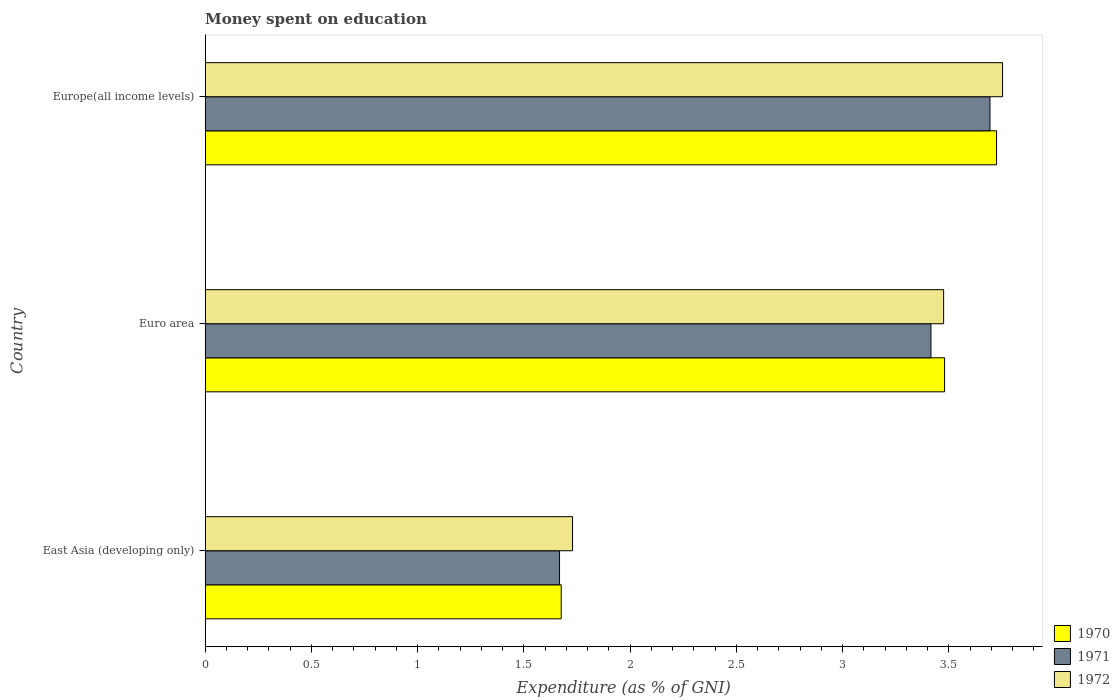How many groups of bars are there?
Offer a very short reply. 3. Are the number of bars on each tick of the Y-axis equal?
Keep it short and to the point. Yes. How many bars are there on the 1st tick from the top?
Keep it short and to the point. 3. How many bars are there on the 2nd tick from the bottom?
Keep it short and to the point. 3. What is the label of the 3rd group of bars from the top?
Provide a succinct answer. East Asia (developing only). What is the amount of money spent on education in 1971 in Euro area?
Ensure brevity in your answer.  3.42. Across all countries, what is the maximum amount of money spent on education in 1971?
Give a very brief answer. 3.69. Across all countries, what is the minimum amount of money spent on education in 1970?
Your response must be concise. 1.68. In which country was the amount of money spent on education in 1970 maximum?
Offer a terse response. Europe(all income levels). In which country was the amount of money spent on education in 1970 minimum?
Provide a succinct answer. East Asia (developing only). What is the total amount of money spent on education in 1972 in the graph?
Provide a succinct answer. 8.96. What is the difference between the amount of money spent on education in 1970 in East Asia (developing only) and that in Euro area?
Make the answer very short. -1.8. What is the difference between the amount of money spent on education in 1972 in Europe(all income levels) and the amount of money spent on education in 1971 in East Asia (developing only)?
Keep it short and to the point. 2.08. What is the average amount of money spent on education in 1971 per country?
Ensure brevity in your answer.  2.93. What is the difference between the amount of money spent on education in 1971 and amount of money spent on education in 1970 in Europe(all income levels)?
Provide a succinct answer. -0.03. What is the ratio of the amount of money spent on education in 1972 in Euro area to that in Europe(all income levels)?
Keep it short and to the point. 0.93. Is the amount of money spent on education in 1972 in Euro area less than that in Europe(all income levels)?
Offer a very short reply. Yes. What is the difference between the highest and the second highest amount of money spent on education in 1972?
Make the answer very short. 0.28. What is the difference between the highest and the lowest amount of money spent on education in 1972?
Offer a very short reply. 2.02. In how many countries, is the amount of money spent on education in 1972 greater than the average amount of money spent on education in 1972 taken over all countries?
Your answer should be compact. 2. Is the sum of the amount of money spent on education in 1971 in East Asia (developing only) and Euro area greater than the maximum amount of money spent on education in 1970 across all countries?
Your answer should be compact. Yes. What does the 2nd bar from the top in Europe(all income levels) represents?
Ensure brevity in your answer.  1971. What does the 1st bar from the bottom in Europe(all income levels) represents?
Provide a succinct answer. 1970. Are all the bars in the graph horizontal?
Provide a succinct answer. Yes. What is the difference between two consecutive major ticks on the X-axis?
Keep it short and to the point. 0.5. Are the values on the major ticks of X-axis written in scientific E-notation?
Your answer should be very brief. No. Where does the legend appear in the graph?
Offer a terse response. Bottom right. How many legend labels are there?
Your answer should be very brief. 3. What is the title of the graph?
Offer a terse response. Money spent on education. Does "2010" appear as one of the legend labels in the graph?
Give a very brief answer. No. What is the label or title of the X-axis?
Your response must be concise. Expenditure (as % of GNI). What is the Expenditure (as % of GNI) of 1970 in East Asia (developing only)?
Keep it short and to the point. 1.68. What is the Expenditure (as % of GNI) of 1971 in East Asia (developing only)?
Provide a short and direct response. 1.67. What is the Expenditure (as % of GNI) in 1972 in East Asia (developing only)?
Provide a short and direct response. 1.73. What is the Expenditure (as % of GNI) of 1970 in Euro area?
Offer a terse response. 3.48. What is the Expenditure (as % of GNI) of 1971 in Euro area?
Your answer should be compact. 3.42. What is the Expenditure (as % of GNI) in 1972 in Euro area?
Provide a succinct answer. 3.47. What is the Expenditure (as % of GNI) of 1970 in Europe(all income levels)?
Ensure brevity in your answer.  3.72. What is the Expenditure (as % of GNI) in 1971 in Europe(all income levels)?
Your response must be concise. 3.69. What is the Expenditure (as % of GNI) of 1972 in Europe(all income levels)?
Provide a short and direct response. 3.75. Across all countries, what is the maximum Expenditure (as % of GNI) in 1970?
Your response must be concise. 3.72. Across all countries, what is the maximum Expenditure (as % of GNI) of 1971?
Offer a very short reply. 3.69. Across all countries, what is the maximum Expenditure (as % of GNI) of 1972?
Make the answer very short. 3.75. Across all countries, what is the minimum Expenditure (as % of GNI) in 1970?
Keep it short and to the point. 1.68. Across all countries, what is the minimum Expenditure (as % of GNI) of 1971?
Your answer should be very brief. 1.67. Across all countries, what is the minimum Expenditure (as % of GNI) in 1972?
Offer a very short reply. 1.73. What is the total Expenditure (as % of GNI) in 1970 in the graph?
Provide a succinct answer. 8.88. What is the total Expenditure (as % of GNI) in 1971 in the graph?
Offer a terse response. 8.78. What is the total Expenditure (as % of GNI) of 1972 in the graph?
Ensure brevity in your answer.  8.96. What is the difference between the Expenditure (as % of GNI) of 1970 in East Asia (developing only) and that in Euro area?
Make the answer very short. -1.8. What is the difference between the Expenditure (as % of GNI) of 1971 in East Asia (developing only) and that in Euro area?
Ensure brevity in your answer.  -1.75. What is the difference between the Expenditure (as % of GNI) of 1972 in East Asia (developing only) and that in Euro area?
Your answer should be compact. -1.75. What is the difference between the Expenditure (as % of GNI) of 1970 in East Asia (developing only) and that in Europe(all income levels)?
Give a very brief answer. -2.05. What is the difference between the Expenditure (as % of GNI) of 1971 in East Asia (developing only) and that in Europe(all income levels)?
Your response must be concise. -2.03. What is the difference between the Expenditure (as % of GNI) in 1972 in East Asia (developing only) and that in Europe(all income levels)?
Ensure brevity in your answer.  -2.02. What is the difference between the Expenditure (as % of GNI) of 1970 in Euro area and that in Europe(all income levels)?
Ensure brevity in your answer.  -0.24. What is the difference between the Expenditure (as % of GNI) of 1971 in Euro area and that in Europe(all income levels)?
Your answer should be compact. -0.28. What is the difference between the Expenditure (as % of GNI) in 1972 in Euro area and that in Europe(all income levels)?
Provide a succinct answer. -0.28. What is the difference between the Expenditure (as % of GNI) of 1970 in East Asia (developing only) and the Expenditure (as % of GNI) of 1971 in Euro area?
Provide a short and direct response. -1.74. What is the difference between the Expenditure (as % of GNI) in 1970 in East Asia (developing only) and the Expenditure (as % of GNI) in 1972 in Euro area?
Your answer should be very brief. -1.8. What is the difference between the Expenditure (as % of GNI) in 1971 in East Asia (developing only) and the Expenditure (as % of GNI) in 1972 in Euro area?
Ensure brevity in your answer.  -1.81. What is the difference between the Expenditure (as % of GNI) in 1970 in East Asia (developing only) and the Expenditure (as % of GNI) in 1971 in Europe(all income levels)?
Provide a succinct answer. -2.02. What is the difference between the Expenditure (as % of GNI) in 1970 in East Asia (developing only) and the Expenditure (as % of GNI) in 1972 in Europe(all income levels)?
Keep it short and to the point. -2.08. What is the difference between the Expenditure (as % of GNI) of 1971 in East Asia (developing only) and the Expenditure (as % of GNI) of 1972 in Europe(all income levels)?
Provide a short and direct response. -2.08. What is the difference between the Expenditure (as % of GNI) in 1970 in Euro area and the Expenditure (as % of GNI) in 1971 in Europe(all income levels)?
Your answer should be very brief. -0.21. What is the difference between the Expenditure (as % of GNI) of 1970 in Euro area and the Expenditure (as % of GNI) of 1972 in Europe(all income levels)?
Your response must be concise. -0.27. What is the difference between the Expenditure (as % of GNI) in 1971 in Euro area and the Expenditure (as % of GNI) in 1972 in Europe(all income levels)?
Your answer should be compact. -0.34. What is the average Expenditure (as % of GNI) of 1970 per country?
Offer a terse response. 2.96. What is the average Expenditure (as % of GNI) in 1971 per country?
Provide a short and direct response. 2.93. What is the average Expenditure (as % of GNI) of 1972 per country?
Give a very brief answer. 2.99. What is the difference between the Expenditure (as % of GNI) in 1970 and Expenditure (as % of GNI) in 1971 in East Asia (developing only)?
Your answer should be very brief. 0.01. What is the difference between the Expenditure (as % of GNI) of 1970 and Expenditure (as % of GNI) of 1972 in East Asia (developing only)?
Keep it short and to the point. -0.05. What is the difference between the Expenditure (as % of GNI) in 1971 and Expenditure (as % of GNI) in 1972 in East Asia (developing only)?
Provide a short and direct response. -0.06. What is the difference between the Expenditure (as % of GNI) of 1970 and Expenditure (as % of GNI) of 1971 in Euro area?
Give a very brief answer. 0.06. What is the difference between the Expenditure (as % of GNI) of 1970 and Expenditure (as % of GNI) of 1972 in Euro area?
Keep it short and to the point. 0. What is the difference between the Expenditure (as % of GNI) of 1971 and Expenditure (as % of GNI) of 1972 in Euro area?
Ensure brevity in your answer.  -0.06. What is the difference between the Expenditure (as % of GNI) in 1970 and Expenditure (as % of GNI) in 1971 in Europe(all income levels)?
Offer a very short reply. 0.03. What is the difference between the Expenditure (as % of GNI) in 1970 and Expenditure (as % of GNI) in 1972 in Europe(all income levels)?
Give a very brief answer. -0.03. What is the difference between the Expenditure (as % of GNI) in 1971 and Expenditure (as % of GNI) in 1972 in Europe(all income levels)?
Give a very brief answer. -0.06. What is the ratio of the Expenditure (as % of GNI) of 1970 in East Asia (developing only) to that in Euro area?
Your answer should be compact. 0.48. What is the ratio of the Expenditure (as % of GNI) in 1971 in East Asia (developing only) to that in Euro area?
Your answer should be very brief. 0.49. What is the ratio of the Expenditure (as % of GNI) in 1972 in East Asia (developing only) to that in Euro area?
Provide a succinct answer. 0.5. What is the ratio of the Expenditure (as % of GNI) in 1970 in East Asia (developing only) to that in Europe(all income levels)?
Keep it short and to the point. 0.45. What is the ratio of the Expenditure (as % of GNI) in 1971 in East Asia (developing only) to that in Europe(all income levels)?
Your response must be concise. 0.45. What is the ratio of the Expenditure (as % of GNI) of 1972 in East Asia (developing only) to that in Europe(all income levels)?
Provide a succinct answer. 0.46. What is the ratio of the Expenditure (as % of GNI) of 1970 in Euro area to that in Europe(all income levels)?
Provide a succinct answer. 0.93. What is the ratio of the Expenditure (as % of GNI) in 1971 in Euro area to that in Europe(all income levels)?
Make the answer very short. 0.92. What is the ratio of the Expenditure (as % of GNI) of 1972 in Euro area to that in Europe(all income levels)?
Make the answer very short. 0.93. What is the difference between the highest and the second highest Expenditure (as % of GNI) in 1970?
Give a very brief answer. 0.24. What is the difference between the highest and the second highest Expenditure (as % of GNI) in 1971?
Offer a terse response. 0.28. What is the difference between the highest and the second highest Expenditure (as % of GNI) of 1972?
Give a very brief answer. 0.28. What is the difference between the highest and the lowest Expenditure (as % of GNI) of 1970?
Offer a very short reply. 2.05. What is the difference between the highest and the lowest Expenditure (as % of GNI) of 1971?
Offer a terse response. 2.03. What is the difference between the highest and the lowest Expenditure (as % of GNI) of 1972?
Your answer should be very brief. 2.02. 